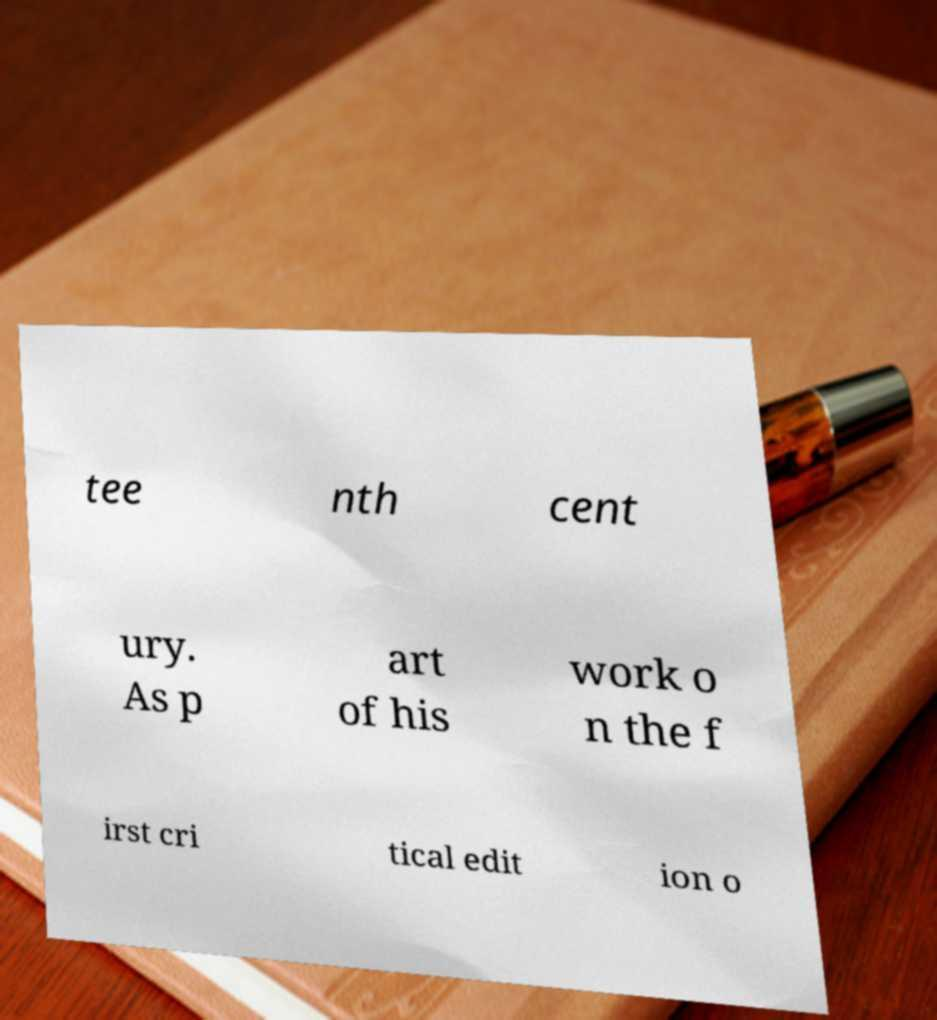Can you accurately transcribe the text from the provided image for me? tee nth cent ury. As p art of his work o n the f irst cri tical edit ion o 